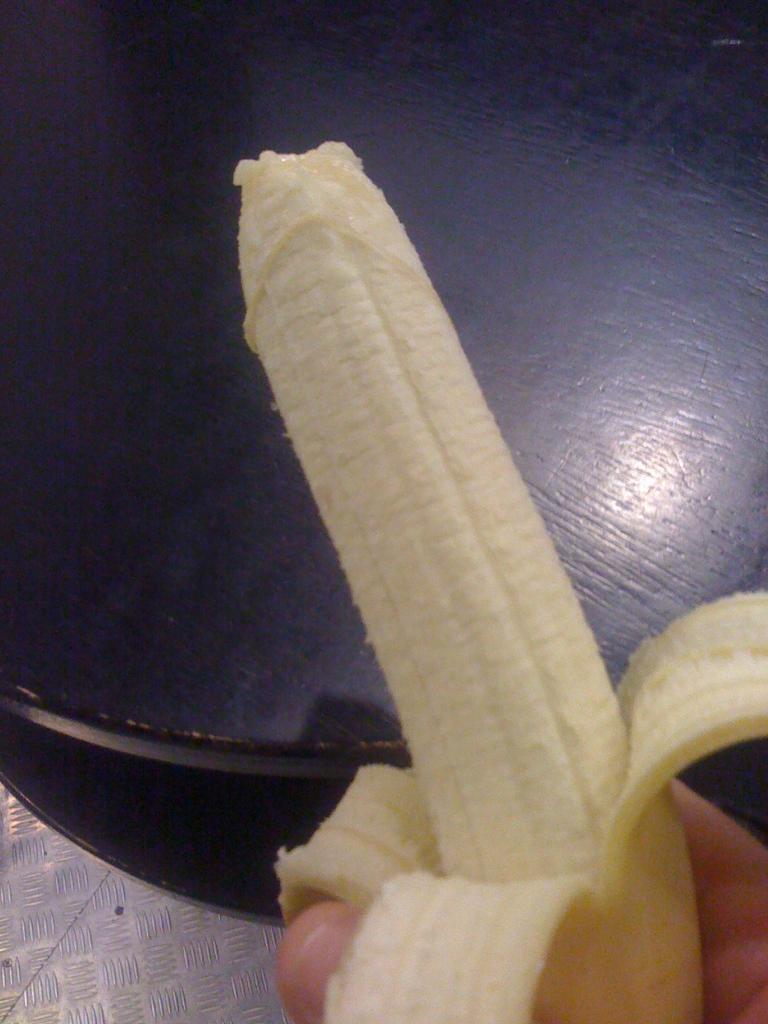Please provide a concise description of this image. At the bottom of this image I can see a person´a hand holding a banana. At the top there is a table placed on the floor. 